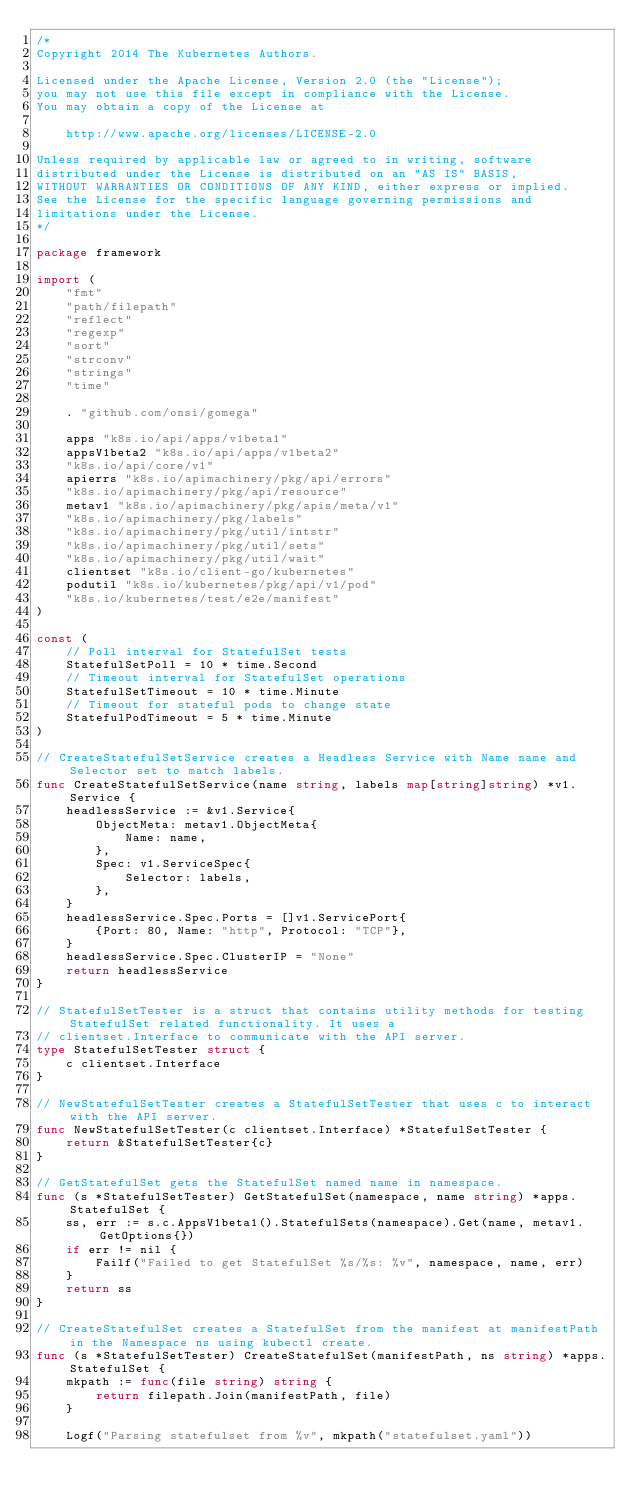Convert code to text. <code><loc_0><loc_0><loc_500><loc_500><_Go_>/*
Copyright 2014 The Kubernetes Authors.

Licensed under the Apache License, Version 2.0 (the "License");
you may not use this file except in compliance with the License.
You may obtain a copy of the License at

    http://www.apache.org/licenses/LICENSE-2.0

Unless required by applicable law or agreed to in writing, software
distributed under the License is distributed on an "AS IS" BASIS,
WITHOUT WARRANTIES OR CONDITIONS OF ANY KIND, either express or implied.
See the License for the specific language governing permissions and
limitations under the License.
*/

package framework

import (
	"fmt"
	"path/filepath"
	"reflect"
	"regexp"
	"sort"
	"strconv"
	"strings"
	"time"

	. "github.com/onsi/gomega"

	apps "k8s.io/api/apps/v1beta1"
	appsV1beta2 "k8s.io/api/apps/v1beta2"
	"k8s.io/api/core/v1"
	apierrs "k8s.io/apimachinery/pkg/api/errors"
	"k8s.io/apimachinery/pkg/api/resource"
	metav1 "k8s.io/apimachinery/pkg/apis/meta/v1"
	"k8s.io/apimachinery/pkg/labels"
	"k8s.io/apimachinery/pkg/util/intstr"
	"k8s.io/apimachinery/pkg/util/sets"
	"k8s.io/apimachinery/pkg/util/wait"
	clientset "k8s.io/client-go/kubernetes"
	podutil "k8s.io/kubernetes/pkg/api/v1/pod"
	"k8s.io/kubernetes/test/e2e/manifest"
)

const (
	// Poll interval for StatefulSet tests
	StatefulSetPoll = 10 * time.Second
	// Timeout interval for StatefulSet operations
	StatefulSetTimeout = 10 * time.Minute
	// Timeout for stateful pods to change state
	StatefulPodTimeout = 5 * time.Minute
)

// CreateStatefulSetService creates a Headless Service with Name name and Selector set to match labels.
func CreateStatefulSetService(name string, labels map[string]string) *v1.Service {
	headlessService := &v1.Service{
		ObjectMeta: metav1.ObjectMeta{
			Name: name,
		},
		Spec: v1.ServiceSpec{
			Selector: labels,
		},
	}
	headlessService.Spec.Ports = []v1.ServicePort{
		{Port: 80, Name: "http", Protocol: "TCP"},
	}
	headlessService.Spec.ClusterIP = "None"
	return headlessService
}

// StatefulSetTester is a struct that contains utility methods for testing StatefulSet related functionality. It uses a
// clientset.Interface to communicate with the API server.
type StatefulSetTester struct {
	c clientset.Interface
}

// NewStatefulSetTester creates a StatefulSetTester that uses c to interact with the API server.
func NewStatefulSetTester(c clientset.Interface) *StatefulSetTester {
	return &StatefulSetTester{c}
}

// GetStatefulSet gets the StatefulSet named name in namespace.
func (s *StatefulSetTester) GetStatefulSet(namespace, name string) *apps.StatefulSet {
	ss, err := s.c.AppsV1beta1().StatefulSets(namespace).Get(name, metav1.GetOptions{})
	if err != nil {
		Failf("Failed to get StatefulSet %s/%s: %v", namespace, name, err)
	}
	return ss
}

// CreateStatefulSet creates a StatefulSet from the manifest at manifestPath in the Namespace ns using kubectl create.
func (s *StatefulSetTester) CreateStatefulSet(manifestPath, ns string) *apps.StatefulSet {
	mkpath := func(file string) string {
		return filepath.Join(manifestPath, file)
	}

	Logf("Parsing statefulset from %v", mkpath("statefulset.yaml"))</code> 